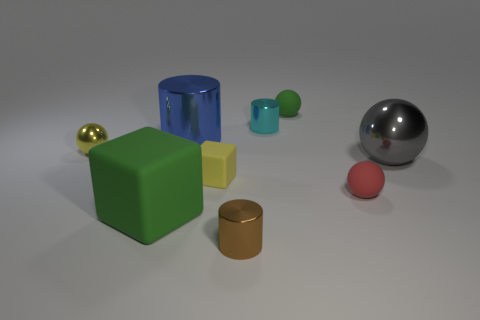There is a rubber cube that is on the left side of the large blue metallic cylinder; what number of small metallic spheres are behind it?
Provide a succinct answer. 1. There is a tiny thing that is to the left of the small brown shiny object and behind the gray shiny thing; what is its material?
Ensure brevity in your answer.  Metal. Do the large gray shiny thing that is to the right of the tiny red matte ball and the small brown shiny thing have the same shape?
Provide a succinct answer. No. Are there fewer large blue objects than big gray metallic cylinders?
Give a very brief answer. No. How many other things are the same color as the big rubber object?
Offer a terse response. 1. There is a tiny cube that is the same color as the tiny shiny sphere; what is its material?
Your answer should be compact. Rubber. There is a small rubber block; is its color the same as the metallic thing on the left side of the big green block?
Keep it short and to the point. Yes. Is the number of tiny gray metallic cylinders greater than the number of green things?
Your response must be concise. No. The yellow thing that is the same shape as the large gray thing is what size?
Give a very brief answer. Small. Is the green block made of the same material as the yellow thing that is to the right of the blue thing?
Your response must be concise. Yes. 